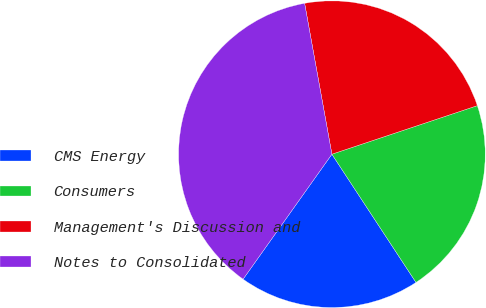Convert chart to OTSL. <chart><loc_0><loc_0><loc_500><loc_500><pie_chart><fcel>CMS Energy<fcel>Consumers<fcel>Management's Discussion and<fcel>Notes to Consolidated<nl><fcel>19.07%<fcel>20.89%<fcel>22.72%<fcel>37.32%<nl></chart> 